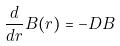Convert formula to latex. <formula><loc_0><loc_0><loc_500><loc_500>\frac { d } { d r } B ( r ) = - D B</formula> 